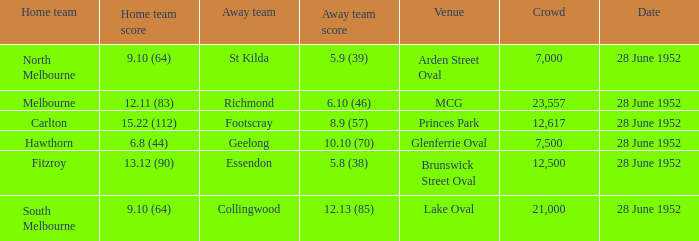10 (64)? St Kilda. Parse the table in full. {'header': ['Home team', 'Home team score', 'Away team', 'Away team score', 'Venue', 'Crowd', 'Date'], 'rows': [['North Melbourne', '9.10 (64)', 'St Kilda', '5.9 (39)', 'Arden Street Oval', '7,000', '28 June 1952'], ['Melbourne', '12.11 (83)', 'Richmond', '6.10 (46)', 'MCG', '23,557', '28 June 1952'], ['Carlton', '15.22 (112)', 'Footscray', '8.9 (57)', 'Princes Park', '12,617', '28 June 1952'], ['Hawthorn', '6.8 (44)', 'Geelong', '10.10 (70)', 'Glenferrie Oval', '7,500', '28 June 1952'], ['Fitzroy', '13.12 (90)', 'Essendon', '5.8 (38)', 'Brunswick Street Oval', '12,500', '28 June 1952'], ['South Melbourne', '9.10 (64)', 'Collingwood', '12.13 (85)', 'Lake Oval', '21,000', '28 June 1952']]} 